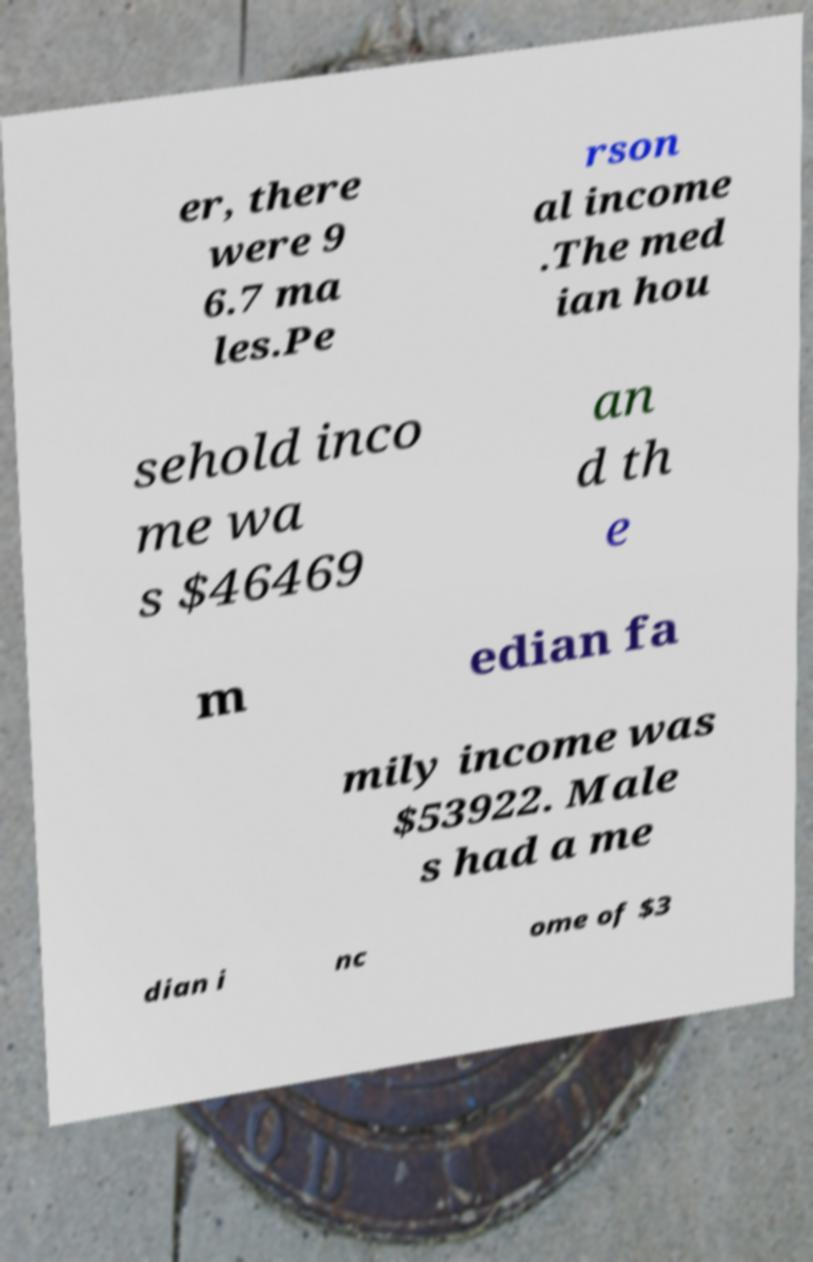Please read and relay the text visible in this image. What does it say? er, there were 9 6.7 ma les.Pe rson al income .The med ian hou sehold inco me wa s $46469 an d th e m edian fa mily income was $53922. Male s had a me dian i nc ome of $3 